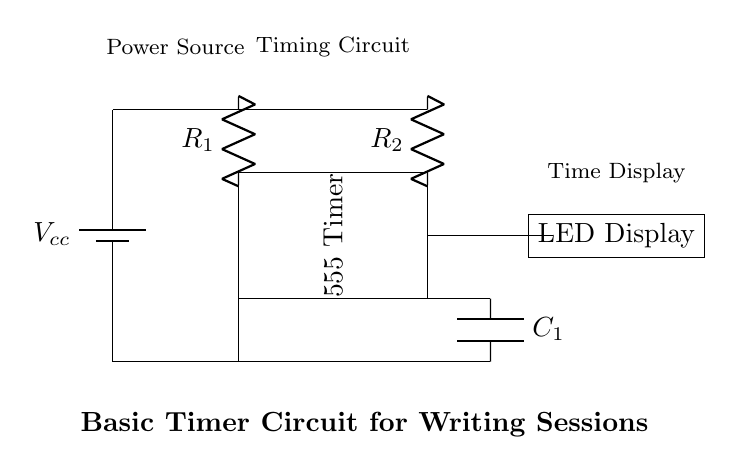What is the main component used for timing in the circuit? The main component for timing is the 555 Timer IC, which is recognized as the heart of the timing mechanism in this circuit.
Answer: 555 Timer How many resistors are present in the circuit? There are two resistors labeled as R1 and R2, shown in the diagram above the 555 Timer IC, indicating a total of two resistors in the circuit.
Answer: 2 What type of display is used to show the time? The circuit utilizes an LED Display, which is shown connected to the output of the timer, indicating that it visually presents the timer's output.
Answer: LED Display What is the purpose of the capacitor in this circuit? The capacitor, labeled C1, works in conjunction with the resistors and the timer to define the timing intervals of the circuit, storing and releasing charge to influence the timing behavior.
Answer: Timing intervals What connects the power source to the timers and components? The circuit connects the power source directly to the resistors and the timer through the power lines, enabling voltage supply to the active components and affecting the operational functionality.
Answer: Power lines What happens to the LED display as the timer counts? The LED Display lights up based on the timer's output signal, visually representing the passage of the timed session, responding to changes in the output from the 555 Timer.
Answer: Lights up 